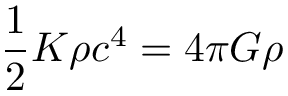Convert formula to latex. <formula><loc_0><loc_0><loc_500><loc_500>{ \frac { 1 } { 2 } } K \rho c ^ { 4 } = 4 \pi G \rho</formula> 